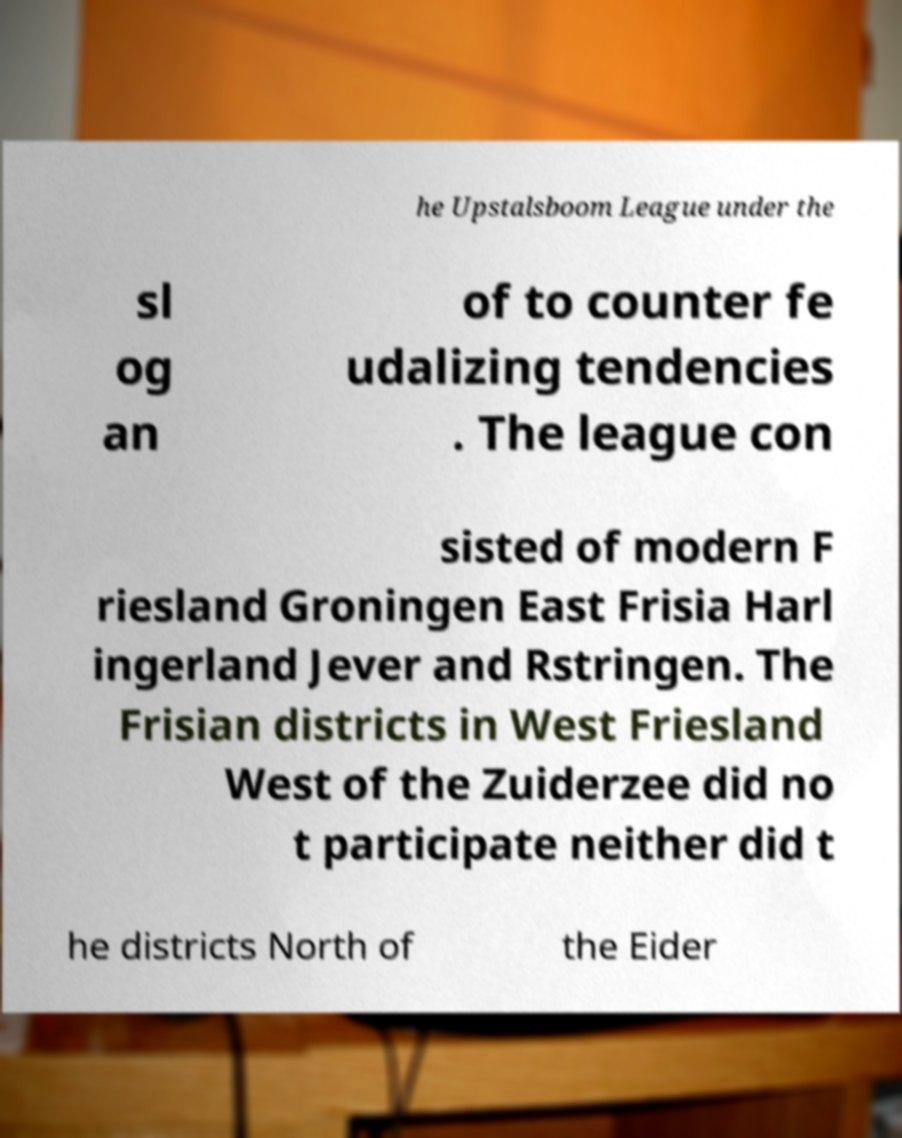What messages or text are displayed in this image? I need them in a readable, typed format. he Upstalsboom League under the sl og an of to counter fe udalizing tendencies . The league con sisted of modern F riesland Groningen East Frisia Harl ingerland Jever and Rstringen. The Frisian districts in West Friesland West of the Zuiderzee did no t participate neither did t he districts North of the Eider 